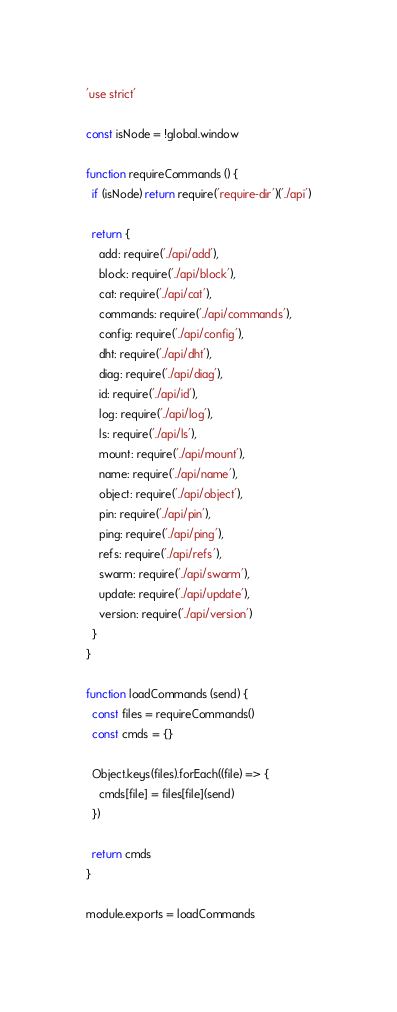<code> <loc_0><loc_0><loc_500><loc_500><_JavaScript_>'use strict'

const isNode = !global.window

function requireCommands () {
  if (isNode) return require('require-dir')('./api')

  return {
    add: require('./api/add'),
    block: require('./api/block'),
    cat: require('./api/cat'),
    commands: require('./api/commands'),
    config: require('./api/config'),
    dht: require('./api/dht'),
    diag: require('./api/diag'),
    id: require('./api/id'),
    log: require('./api/log'),
    ls: require('./api/ls'),
    mount: require('./api/mount'),
    name: require('./api/name'),
    object: require('./api/object'),
    pin: require('./api/pin'),
    ping: require('./api/ping'),
    refs: require('./api/refs'),
    swarm: require('./api/swarm'),
    update: require('./api/update'),
    version: require('./api/version')
  }
}

function loadCommands (send) {
  const files = requireCommands()
  const cmds = {}

  Object.keys(files).forEach((file) => {
    cmds[file] = files[file](send)
  })

  return cmds
}

module.exports = loadCommands
</code> 